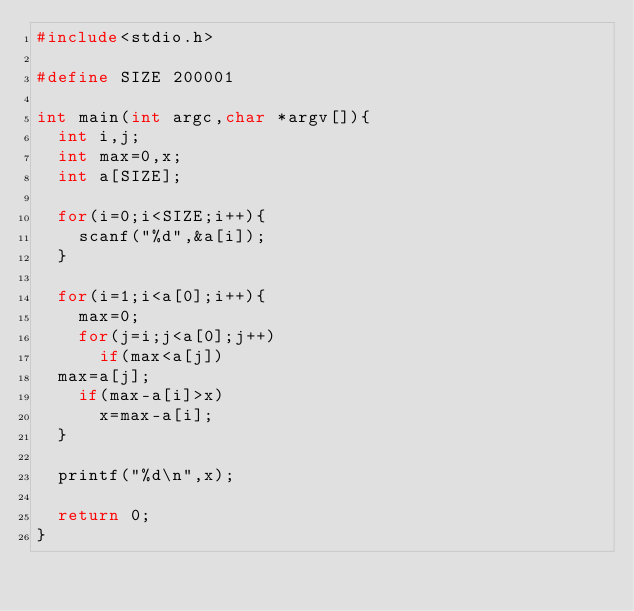Convert code to text. <code><loc_0><loc_0><loc_500><loc_500><_C_>#include<stdio.h>

#define SIZE 200001

int main(int argc,char *argv[]){
  int i,j;
  int max=0,x;
  int a[SIZE];

  for(i=0;i<SIZE;i++){
    scanf("%d",&a[i]);
  }
  
  for(i=1;i<a[0];i++){
    max=0;
    for(j=i;j<a[0];j++)
      if(max<a[j])
	max=a[j];
    if(max-a[i]>x)
      x=max-a[i];
  }

  printf("%d\n",x);

  return 0;
}</code> 